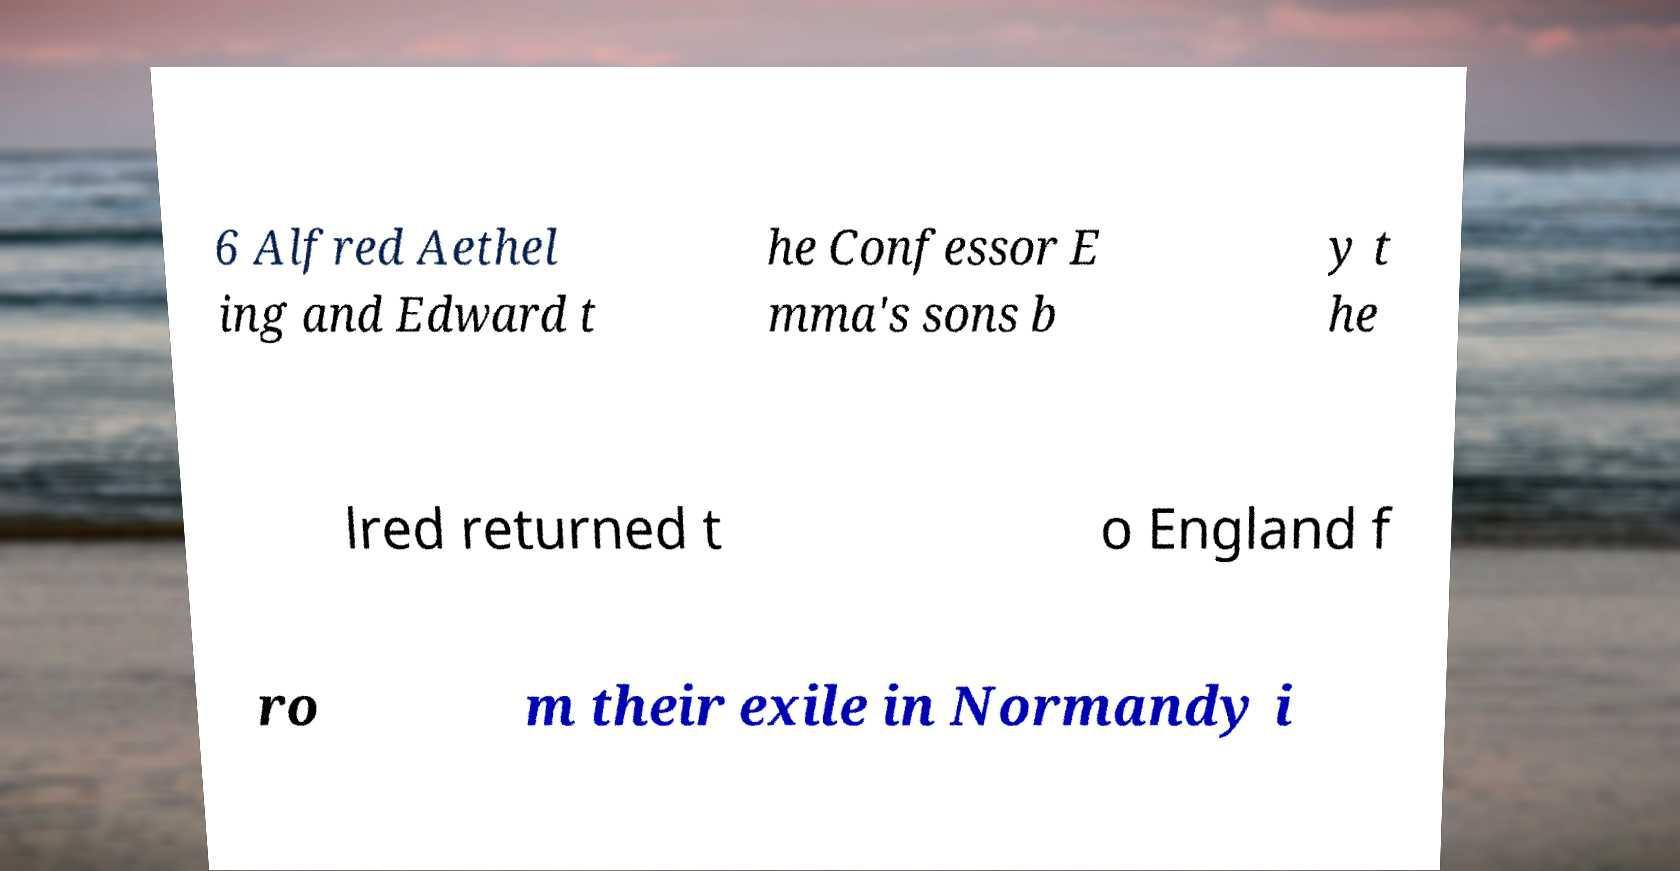Could you extract and type out the text from this image? 6 Alfred Aethel ing and Edward t he Confessor E mma's sons b y t he lred returned t o England f ro m their exile in Normandy i 